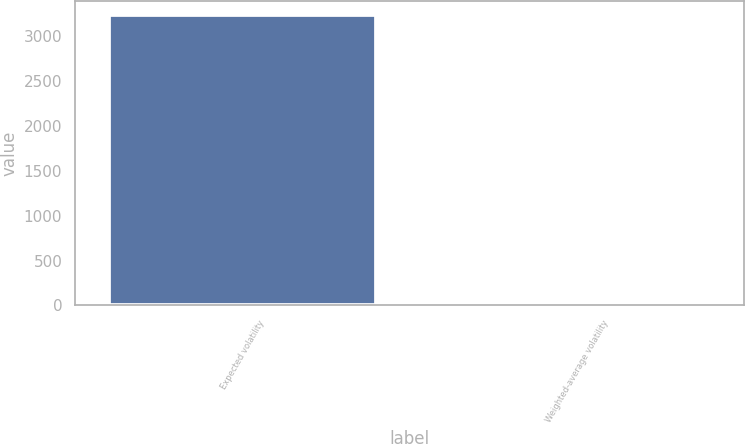Convert chart to OTSL. <chart><loc_0><loc_0><loc_500><loc_500><bar_chart><fcel>Expected volatility<fcel>Weighted-average volatility<nl><fcel>3236<fcel>33<nl></chart> 